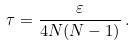<formula> <loc_0><loc_0><loc_500><loc_500>\tau = \frac { \varepsilon } { 4 N ( N - 1 ) } \, .</formula> 